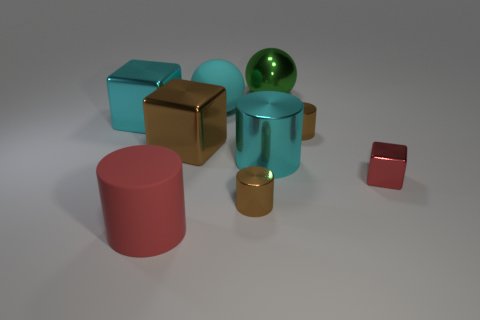Subtract all yellow cylinders. Subtract all red cubes. How many cylinders are left? 4 Add 1 tiny shiny cylinders. How many objects exist? 10 Subtract all cylinders. How many objects are left? 5 Add 9 brown blocks. How many brown blocks are left? 10 Add 2 shiny blocks. How many shiny blocks exist? 5 Subtract 0 green cubes. How many objects are left? 9 Subtract all large purple matte cylinders. Subtract all brown metallic cylinders. How many objects are left? 7 